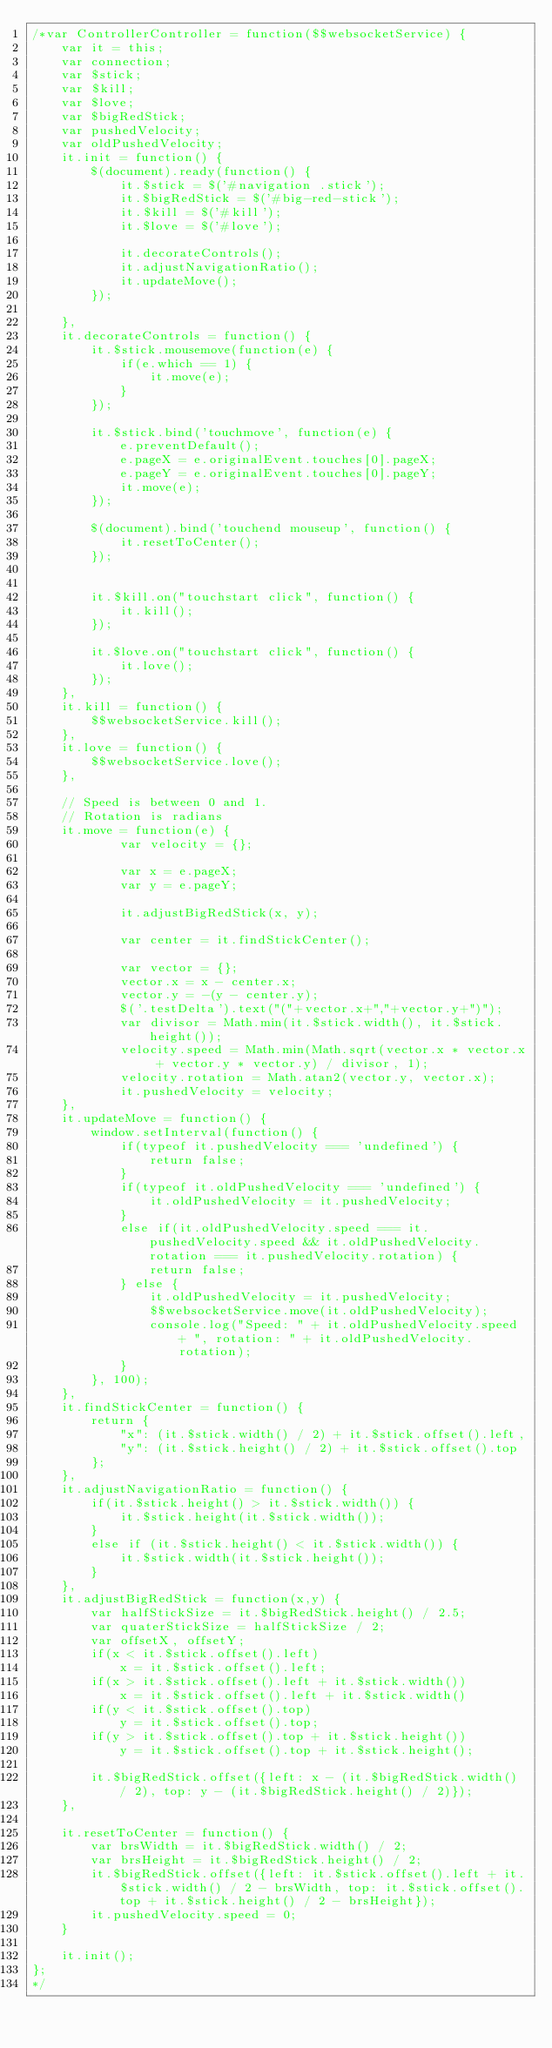<code> <loc_0><loc_0><loc_500><loc_500><_JavaScript_>/*var ControllerController = function($$websocketService) {
	var it = this;
	var connection;
	var $stick;
	var $kill;
	var $love;
	var $bigRedStick;
	var pushedVelocity;
	var oldPushedVelocity;
	it.init = function() {
		$(document).ready(function() {
			it.$stick = $('#navigation .stick');
			it.$bigRedStick = $('#big-red-stick');
			it.$kill = $('#kill');
			it.$love = $('#love');
			
			it.decorateControls();
			it.adjustNavigationRatio();
			it.updateMove();
		});
		
	},
	it.decorateControls = function() {
		it.$stick.mousemove(function(e) {
			if(e.which == 1) {
				it.move(e);
			}
		});

		it.$stick.bind('touchmove', function(e) {
			e.preventDefault();
			e.pageX = e.originalEvent.touches[0].pageX;
			e.pageY = e.originalEvent.touches[0].pageY;
		    it.move(e);
		});

		$(document).bind('touchend mouseup', function() {
			it.resetToCenter();
		});


		it.$kill.on("touchstart click", function() {
			it.kill();
		});

		it.$love.on("touchstart click", function() {
			it.love();
		});
	},
	it.kill = function() {
		$$websocketService.kill();
	},
	it.love = function() {
		$$websocketService.love();
	},

	// Speed is between 0 and 1.
	// Rotation is radians
	it.move = function(e) {
			var velocity = {};

			var x = e.pageX;
			var y = e.pageY; 
			
			it.adjustBigRedStick(x, y);

			var center = it.findStickCenter();

			var vector = {};
			vector.x = x - center.x;
			vector.y = -(y - center.y);
			$('.testDelta').text("("+vector.x+","+vector.y+")");
			var divisor = Math.min(it.$stick.width(), it.$stick.height());
			velocity.speed = Math.min(Math.sqrt(vector.x * vector.x + vector.y * vector.y) / divisor, 1);
			velocity.rotation = Math.atan2(vector.y, vector.x);
			it.pushedVelocity = velocity;
	},
	it.updateMove = function() {
		window.setInterval(function() {
			if(typeof it.pushedVelocity === 'undefined') {
				return false;
			}
			if(typeof it.oldPushedVelocity === 'undefined') {
				it.oldPushedVelocity = it.pushedVelocity;
			}
			else if(it.oldPushedVelocity.speed === it.pushedVelocity.speed && it.oldPushedVelocity.rotation === it.pushedVelocity.rotation) {
				return false;
			} else {
				it.oldPushedVelocity = it.pushedVelocity;
				$$websocketService.move(it.oldPushedVelocity);
				console.log("Speed: " + it.oldPushedVelocity.speed + ", rotation: " + it.oldPushedVelocity.rotation);
			}
		}, 100);
	},
	it.findStickCenter = function() {
		return {
			"x": (it.$stick.width() / 2) + it.$stick.offset().left, 
			"y": (it.$stick.height() / 2) + it.$stick.offset().top
		};
	},
	it.adjustNavigationRatio = function() {
		if(it.$stick.height() > it.$stick.width()) {
			it.$stick.height(it.$stick.width());
		}
		else if (it.$stick.height() < it.$stick.width()) {
			it.$stick.width(it.$stick.height());
		}
	},
	it.adjustBigRedStick = function(x,y) {
		var halfStickSize = it.$bigRedStick.height() / 2.5;
		var quaterStickSize = halfStickSize / 2;
		var offsetX, offsetY;
		if(x < it.$stick.offset().left)
			x = it.$stick.offset().left;
		if(x > it.$stick.offset().left + it.$stick.width())
			x = it.$stick.offset().left + it.$stick.width()
		if(y < it.$stick.offset().top)
			y = it.$stick.offset().top;
		if(y > it.$stick.offset().top + it.$stick.height())
			y = it.$stick.offset().top + it.$stick.height();

		it.$bigRedStick.offset({left: x - (it.$bigRedStick.width() / 2), top: y - (it.$bigRedStick.height() / 2)});
	},

	it.resetToCenter = function() {
		var brsWidth = it.$bigRedStick.width() / 2;
		var brsHeight = it.$bigRedStick.height() / 2;
		it.$bigRedStick.offset({left: it.$stick.offset().left + it.$stick.width() / 2 - brsWidth, top: it.$stick.offset().top + it.$stick.height() / 2 - brsHeight});
		it.pushedVelocity.speed = 0;
	}

	it.init();
};
*/</code> 